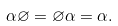<formula> <loc_0><loc_0><loc_500><loc_500>\alpha \varnothing = \varnothing \alpha = \alpha .</formula> 